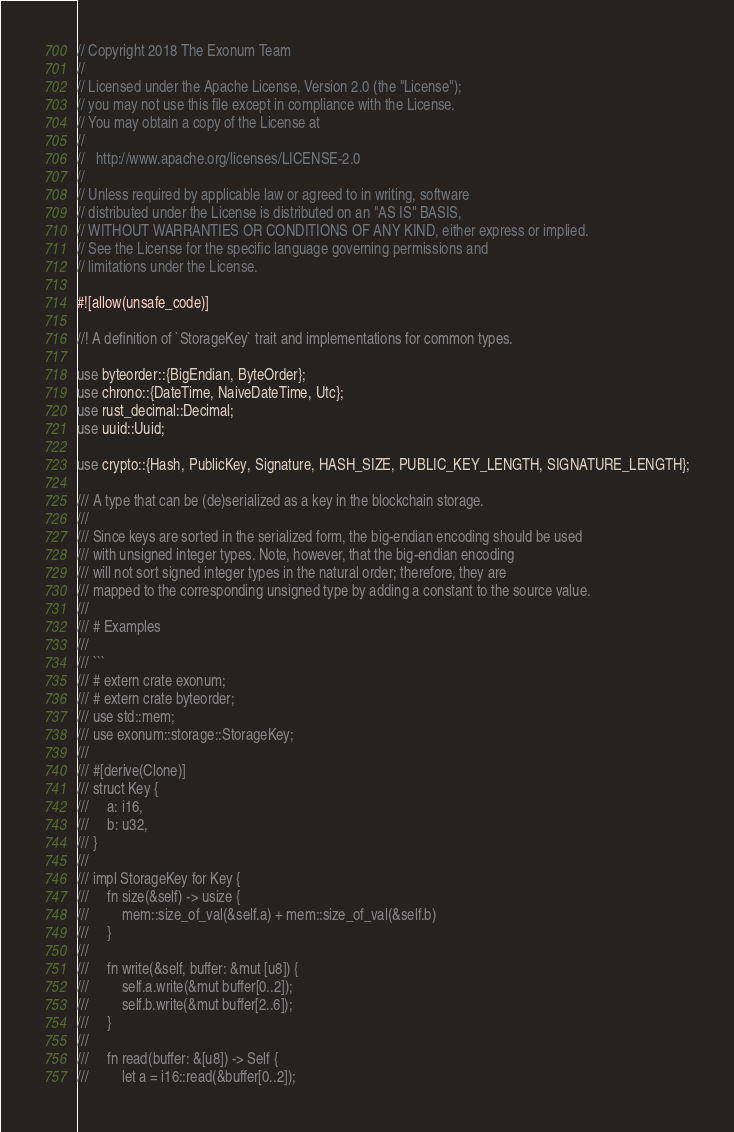Convert code to text. <code><loc_0><loc_0><loc_500><loc_500><_Rust_>// Copyright 2018 The Exonum Team
//
// Licensed under the Apache License, Version 2.0 (the "License");
// you may not use this file except in compliance with the License.
// You may obtain a copy of the License at
//
//   http://www.apache.org/licenses/LICENSE-2.0
//
// Unless required by applicable law or agreed to in writing, software
// distributed under the License is distributed on an "AS IS" BASIS,
// WITHOUT WARRANTIES OR CONDITIONS OF ANY KIND, either express or implied.
// See the License for the specific language governing permissions and
// limitations under the License.

#![allow(unsafe_code)]

//! A definition of `StorageKey` trait and implementations for common types.

use byteorder::{BigEndian, ByteOrder};
use chrono::{DateTime, NaiveDateTime, Utc};
use rust_decimal::Decimal;
use uuid::Uuid;

use crypto::{Hash, PublicKey, Signature, HASH_SIZE, PUBLIC_KEY_LENGTH, SIGNATURE_LENGTH};

/// A type that can be (de)serialized as a key in the blockchain storage.
///
/// Since keys are sorted in the serialized form, the big-endian encoding should be used
/// with unsigned integer types. Note, however, that the big-endian encoding
/// will not sort signed integer types in the natural order; therefore, they are
/// mapped to the corresponding unsigned type by adding a constant to the source value.
///
/// # Examples
///
/// ```
/// # extern crate exonum;
/// # extern crate byteorder;
/// use std::mem;
/// use exonum::storage::StorageKey;
///
/// #[derive(Clone)]
/// struct Key {
///     a: i16,
///     b: u32,
/// }
///
/// impl StorageKey for Key {
///     fn size(&self) -> usize {
///         mem::size_of_val(&self.a) + mem::size_of_val(&self.b)
///     }
///
///     fn write(&self, buffer: &mut [u8]) {
///         self.a.write(&mut buffer[0..2]);
///         self.b.write(&mut buffer[2..6]);
///     }
///
///     fn read(buffer: &[u8]) -> Self {
///         let a = i16::read(&buffer[0..2]);</code> 